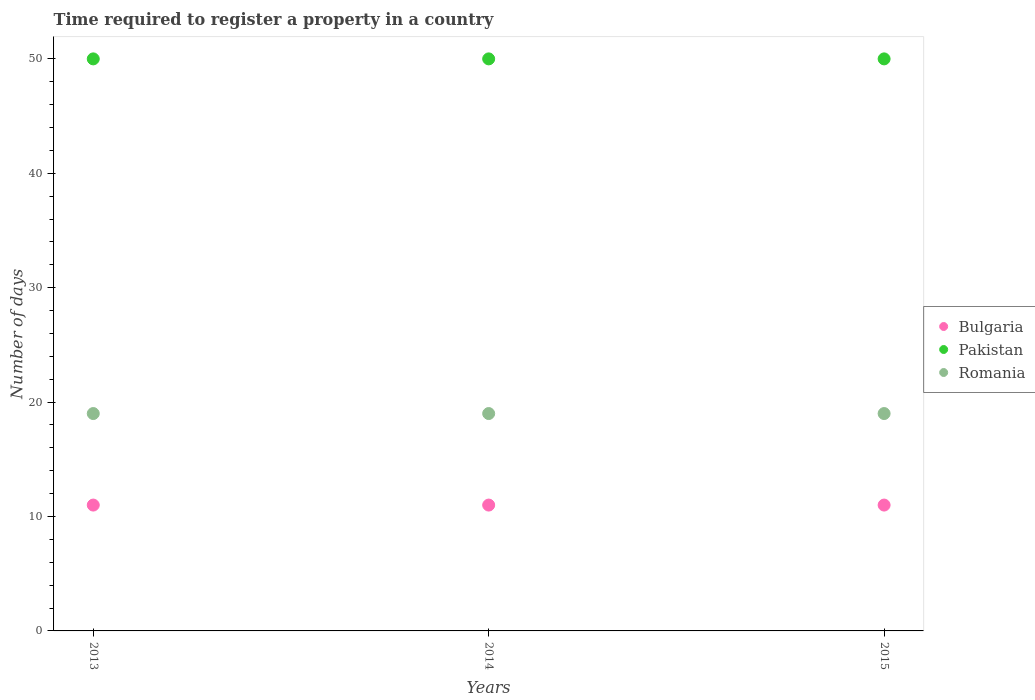Is the number of dotlines equal to the number of legend labels?
Provide a succinct answer. Yes. What is the number of days required to register a property in Pakistan in 2014?
Keep it short and to the point. 50. Across all years, what is the maximum number of days required to register a property in Bulgaria?
Provide a succinct answer. 11. Across all years, what is the minimum number of days required to register a property in Romania?
Give a very brief answer. 19. In which year was the number of days required to register a property in Pakistan minimum?
Offer a very short reply. 2013. What is the total number of days required to register a property in Bulgaria in the graph?
Provide a short and direct response. 33. What is the difference between the number of days required to register a property in Bulgaria in 2015 and the number of days required to register a property in Pakistan in 2013?
Ensure brevity in your answer.  -39. What is the average number of days required to register a property in Pakistan per year?
Your answer should be compact. 50. In the year 2014, what is the difference between the number of days required to register a property in Pakistan and number of days required to register a property in Bulgaria?
Offer a very short reply. 39. In how many years, is the number of days required to register a property in Pakistan greater than 24 days?
Ensure brevity in your answer.  3. What is the difference between the highest and the lowest number of days required to register a property in Romania?
Offer a terse response. 0. Is the sum of the number of days required to register a property in Bulgaria in 2013 and 2015 greater than the maximum number of days required to register a property in Romania across all years?
Offer a terse response. Yes. Does the number of days required to register a property in Pakistan monotonically increase over the years?
Your answer should be very brief. No. Does the graph contain grids?
Provide a short and direct response. No. Where does the legend appear in the graph?
Make the answer very short. Center right. What is the title of the graph?
Your response must be concise. Time required to register a property in a country. Does "Curacao" appear as one of the legend labels in the graph?
Your answer should be very brief. No. What is the label or title of the X-axis?
Ensure brevity in your answer.  Years. What is the label or title of the Y-axis?
Keep it short and to the point. Number of days. What is the Number of days in Bulgaria in 2013?
Offer a very short reply. 11. What is the Number of days of Pakistan in 2013?
Give a very brief answer. 50. What is the Number of days in Bulgaria in 2014?
Your answer should be compact. 11. What is the Number of days in Pakistan in 2014?
Your response must be concise. 50. What is the Number of days in Romania in 2014?
Provide a short and direct response. 19. What is the Number of days in Bulgaria in 2015?
Your answer should be compact. 11. Across all years, what is the maximum Number of days of Bulgaria?
Ensure brevity in your answer.  11. Across all years, what is the maximum Number of days in Pakistan?
Your answer should be very brief. 50. Across all years, what is the maximum Number of days of Romania?
Give a very brief answer. 19. Across all years, what is the minimum Number of days in Romania?
Provide a short and direct response. 19. What is the total Number of days in Pakistan in the graph?
Make the answer very short. 150. What is the total Number of days of Romania in the graph?
Provide a short and direct response. 57. What is the difference between the Number of days in Bulgaria in 2013 and that in 2014?
Keep it short and to the point. 0. What is the difference between the Number of days in Bulgaria in 2013 and that in 2015?
Keep it short and to the point. 0. What is the difference between the Number of days of Bulgaria in 2014 and that in 2015?
Provide a succinct answer. 0. What is the difference between the Number of days of Romania in 2014 and that in 2015?
Ensure brevity in your answer.  0. What is the difference between the Number of days of Bulgaria in 2013 and the Number of days of Pakistan in 2014?
Keep it short and to the point. -39. What is the difference between the Number of days of Bulgaria in 2013 and the Number of days of Pakistan in 2015?
Give a very brief answer. -39. What is the difference between the Number of days in Bulgaria in 2013 and the Number of days in Romania in 2015?
Keep it short and to the point. -8. What is the difference between the Number of days in Bulgaria in 2014 and the Number of days in Pakistan in 2015?
Provide a succinct answer. -39. In the year 2013, what is the difference between the Number of days of Bulgaria and Number of days of Pakistan?
Your answer should be compact. -39. In the year 2013, what is the difference between the Number of days in Pakistan and Number of days in Romania?
Provide a succinct answer. 31. In the year 2014, what is the difference between the Number of days of Bulgaria and Number of days of Pakistan?
Make the answer very short. -39. In the year 2015, what is the difference between the Number of days of Bulgaria and Number of days of Pakistan?
Make the answer very short. -39. What is the ratio of the Number of days of Bulgaria in 2013 to that in 2014?
Your response must be concise. 1. What is the ratio of the Number of days of Bulgaria in 2013 to that in 2015?
Offer a terse response. 1. What is the ratio of the Number of days of Pakistan in 2013 to that in 2015?
Make the answer very short. 1. What is the ratio of the Number of days in Romania in 2013 to that in 2015?
Give a very brief answer. 1. What is the ratio of the Number of days of Bulgaria in 2014 to that in 2015?
Offer a terse response. 1. What is the ratio of the Number of days of Romania in 2014 to that in 2015?
Ensure brevity in your answer.  1. What is the difference between the highest and the second highest Number of days of Bulgaria?
Your response must be concise. 0. What is the difference between the highest and the second highest Number of days of Romania?
Ensure brevity in your answer.  0. What is the difference between the highest and the lowest Number of days of Bulgaria?
Offer a very short reply. 0. What is the difference between the highest and the lowest Number of days in Romania?
Provide a short and direct response. 0. 